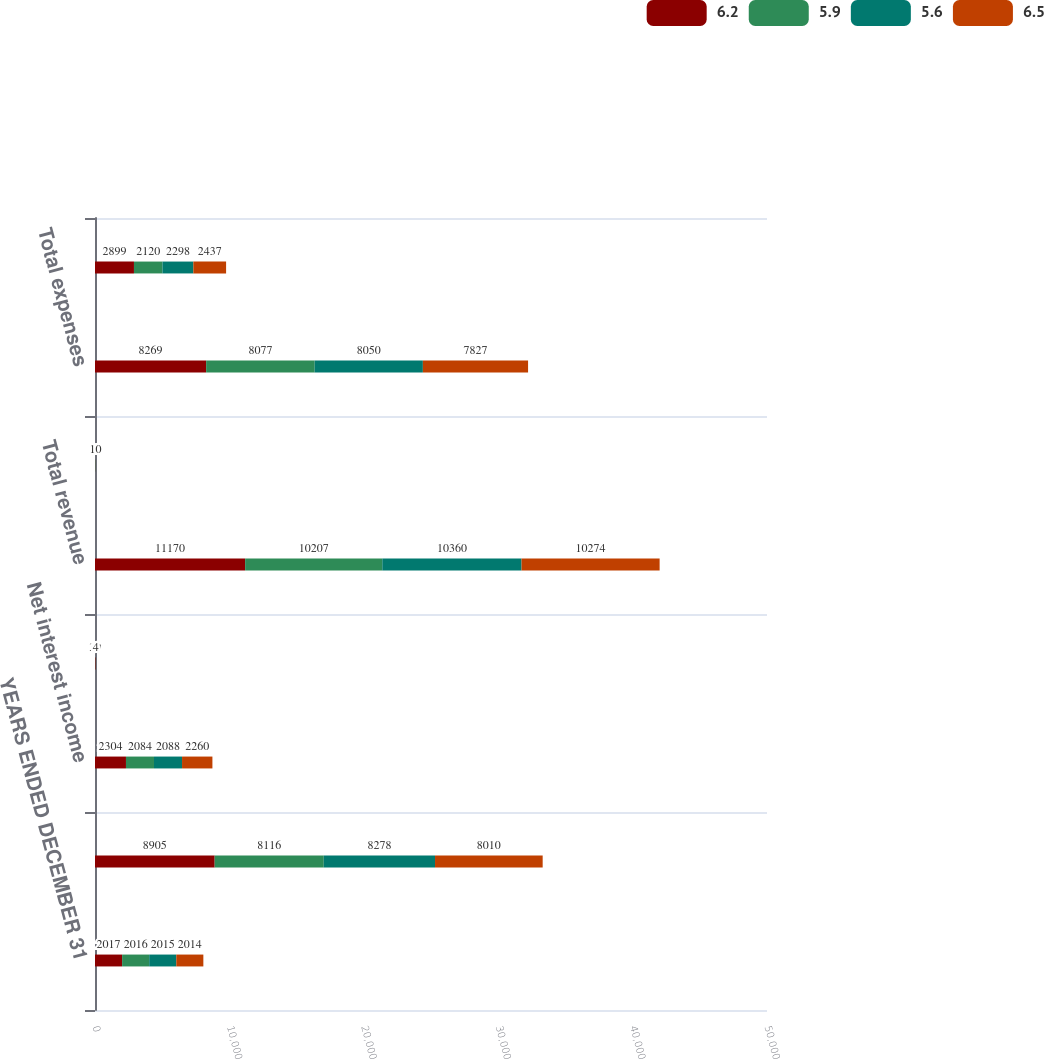Convert chart to OTSL. <chart><loc_0><loc_0><loc_500><loc_500><stacked_bar_chart><ecel><fcel>YEARS ENDED DECEMBER 31<fcel>Total fee revenue<fcel>Net interest income<fcel>Gains (losses) related to<fcel>Total revenue<fcel>Provision for loan losses<fcel>Total expenses<fcel>Income before income tax<nl><fcel>6.2<fcel>2017<fcel>8905<fcel>2304<fcel>39<fcel>11170<fcel>2<fcel>8269<fcel>2899<nl><fcel>5.9<fcel>2016<fcel>8116<fcel>2084<fcel>7<fcel>10207<fcel>10<fcel>8077<fcel>2120<nl><fcel>5.6<fcel>2015<fcel>8278<fcel>2088<fcel>6<fcel>10360<fcel>12<fcel>8050<fcel>2298<nl><fcel>6.5<fcel>2014<fcel>8010<fcel>2260<fcel>4<fcel>10274<fcel>10<fcel>7827<fcel>2437<nl></chart> 